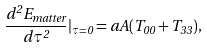<formula> <loc_0><loc_0><loc_500><loc_500>\frac { d ^ { 2 } E _ { m a t t e r } } { d \tau ^ { 2 } } | _ { \tau = 0 } = a A ( T _ { 0 0 } + T _ { 3 3 } ) ,</formula> 